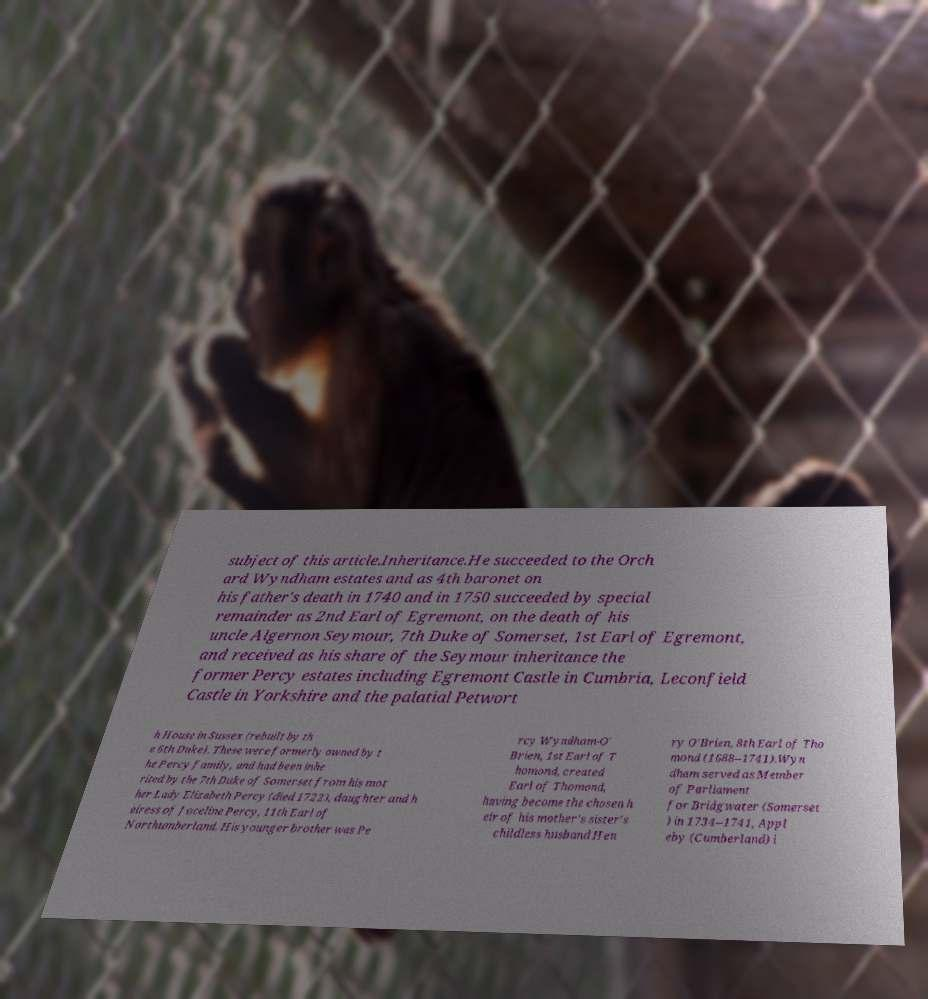Could you assist in decoding the text presented in this image and type it out clearly? subject of this article.Inheritance.He succeeded to the Orch ard Wyndham estates and as 4th baronet on his father's death in 1740 and in 1750 succeeded by special remainder as 2nd Earl of Egremont, on the death of his uncle Algernon Seymour, 7th Duke of Somerset, 1st Earl of Egremont, and received as his share of the Seymour inheritance the former Percy estates including Egremont Castle in Cumbria, Leconfield Castle in Yorkshire and the palatial Petwort h House in Sussex (rebuilt by th e 6th Duke). These were formerly owned by t he Percy family, and had been inhe rited by the 7th Duke of Somerset from his mot her Lady Elizabeth Percy (died 1722), daughter and h eiress of Joceline Percy, 11th Earl of Northumberland. His younger brother was Pe rcy Wyndham-O' Brien, 1st Earl of T homond, created Earl of Thomond, having become the chosen h eir of his mother's sister's childless husband Hen ry O'Brien, 8th Earl of Tho mond (1688–1741).Wyn dham served as Member of Parliament for Bridgwater (Somerset ) in 1734–1741, Appl eby (Cumberland) i 